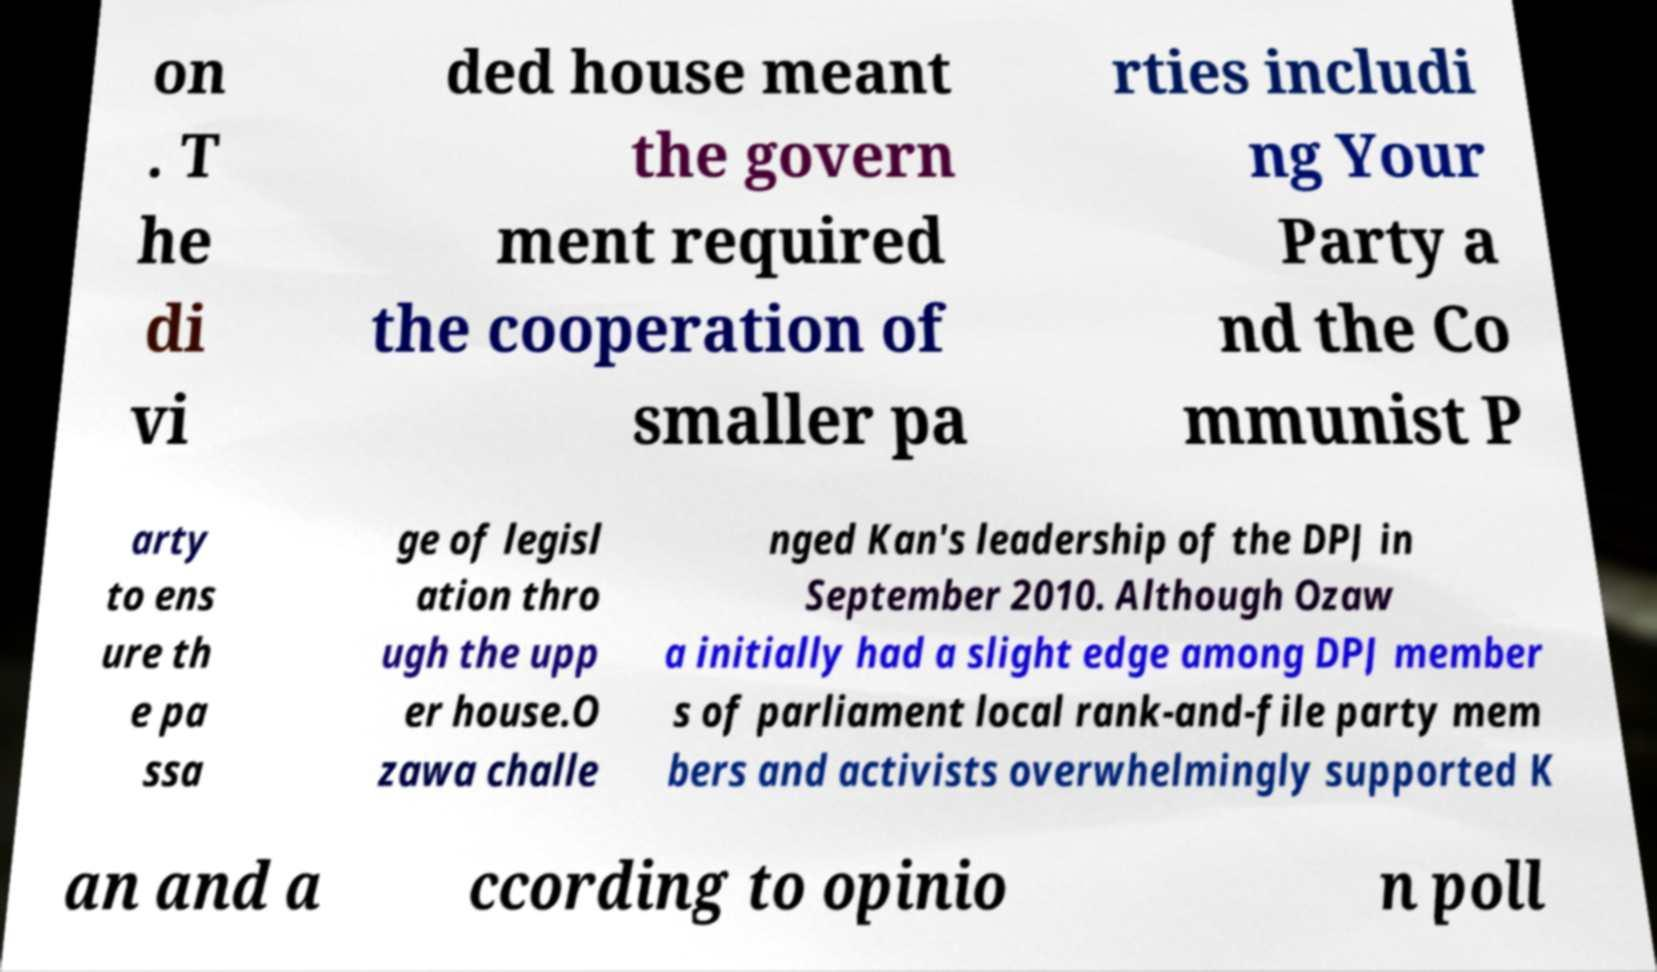Please read and relay the text visible in this image. What does it say? on . T he di vi ded house meant the govern ment required the cooperation of smaller pa rties includi ng Your Party a nd the Co mmunist P arty to ens ure th e pa ssa ge of legisl ation thro ugh the upp er house.O zawa challe nged Kan's leadership of the DPJ in September 2010. Although Ozaw a initially had a slight edge among DPJ member s of parliament local rank-and-file party mem bers and activists overwhelmingly supported K an and a ccording to opinio n poll 